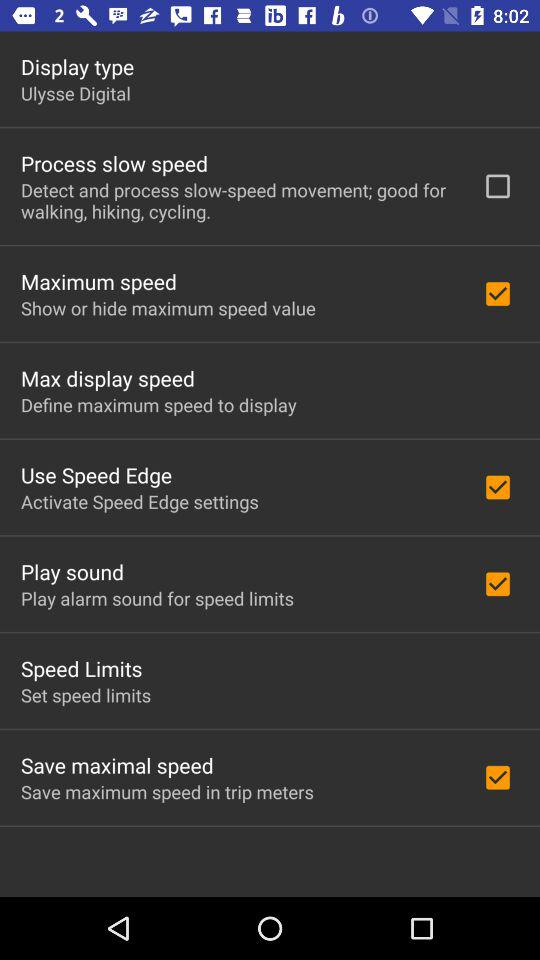What is the status of "Maximum speed"? The status is "on". 